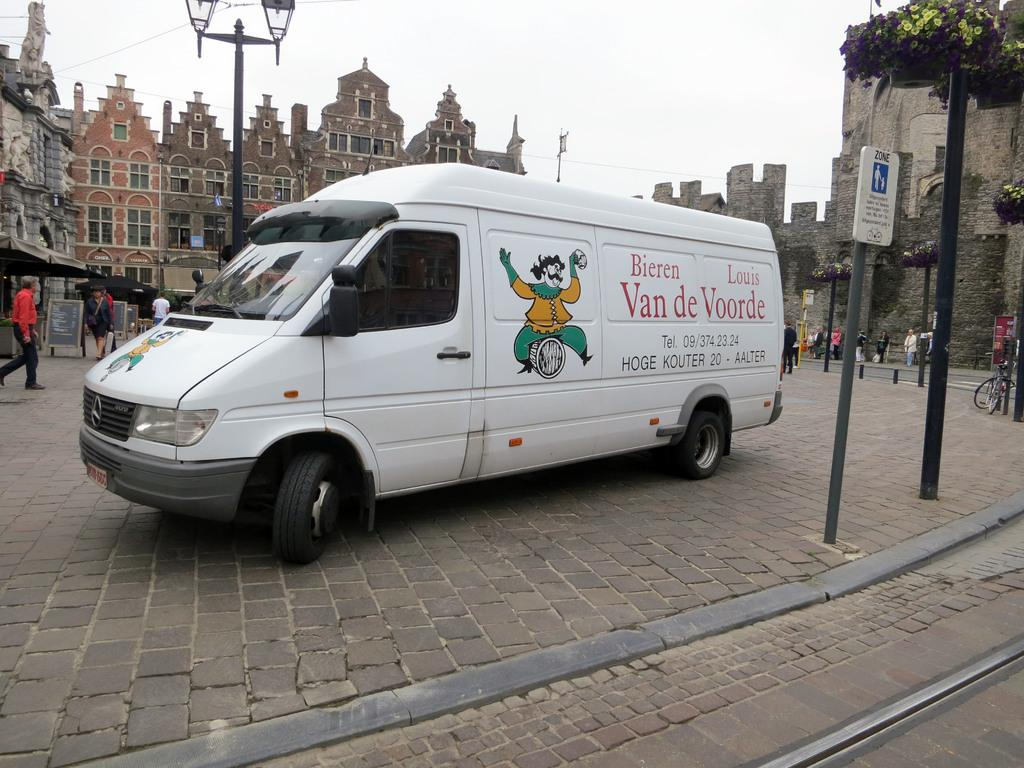<image>
Offer a succinct explanation of the picture presented. A white van has the logo for Van de Voorde on the side. 